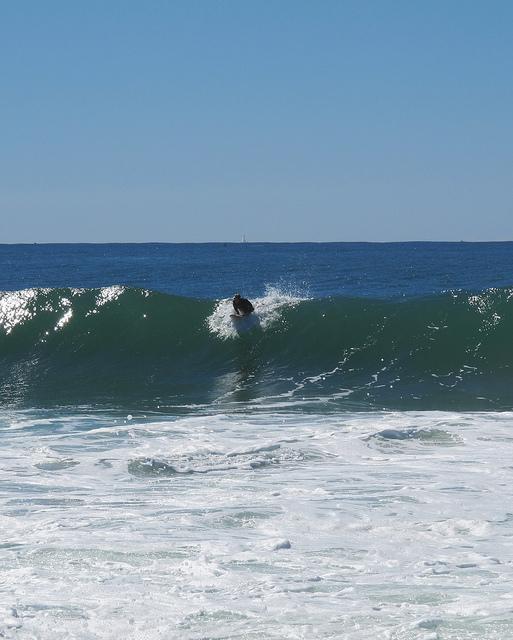What color does the water look around the surfer?
Be succinct. Green. What is in the background?
Answer briefly. Water. How many waves are cresting?
Keep it brief. 1. Is the wave a 'monster' wave?
Answer briefly. No. How many people are in the water?
Be succinct. 1. Was the camera held level?
Be succinct. Yes. Is the water turbulent?
Give a very brief answer. Yes. Is the sky clear?
Quick response, please. Yes. Is there an airplane?
Be succinct. No. Is the man about to surf a wave?
Concise answer only. Yes. What are the weather conditions?
Keep it brief. Sunny. What is in the background of the photo?
Write a very short answer. Ocean. Are the waves breaking?
Keep it brief. Yes. What is the person doing in the water?
Give a very brief answer. Surfing. 